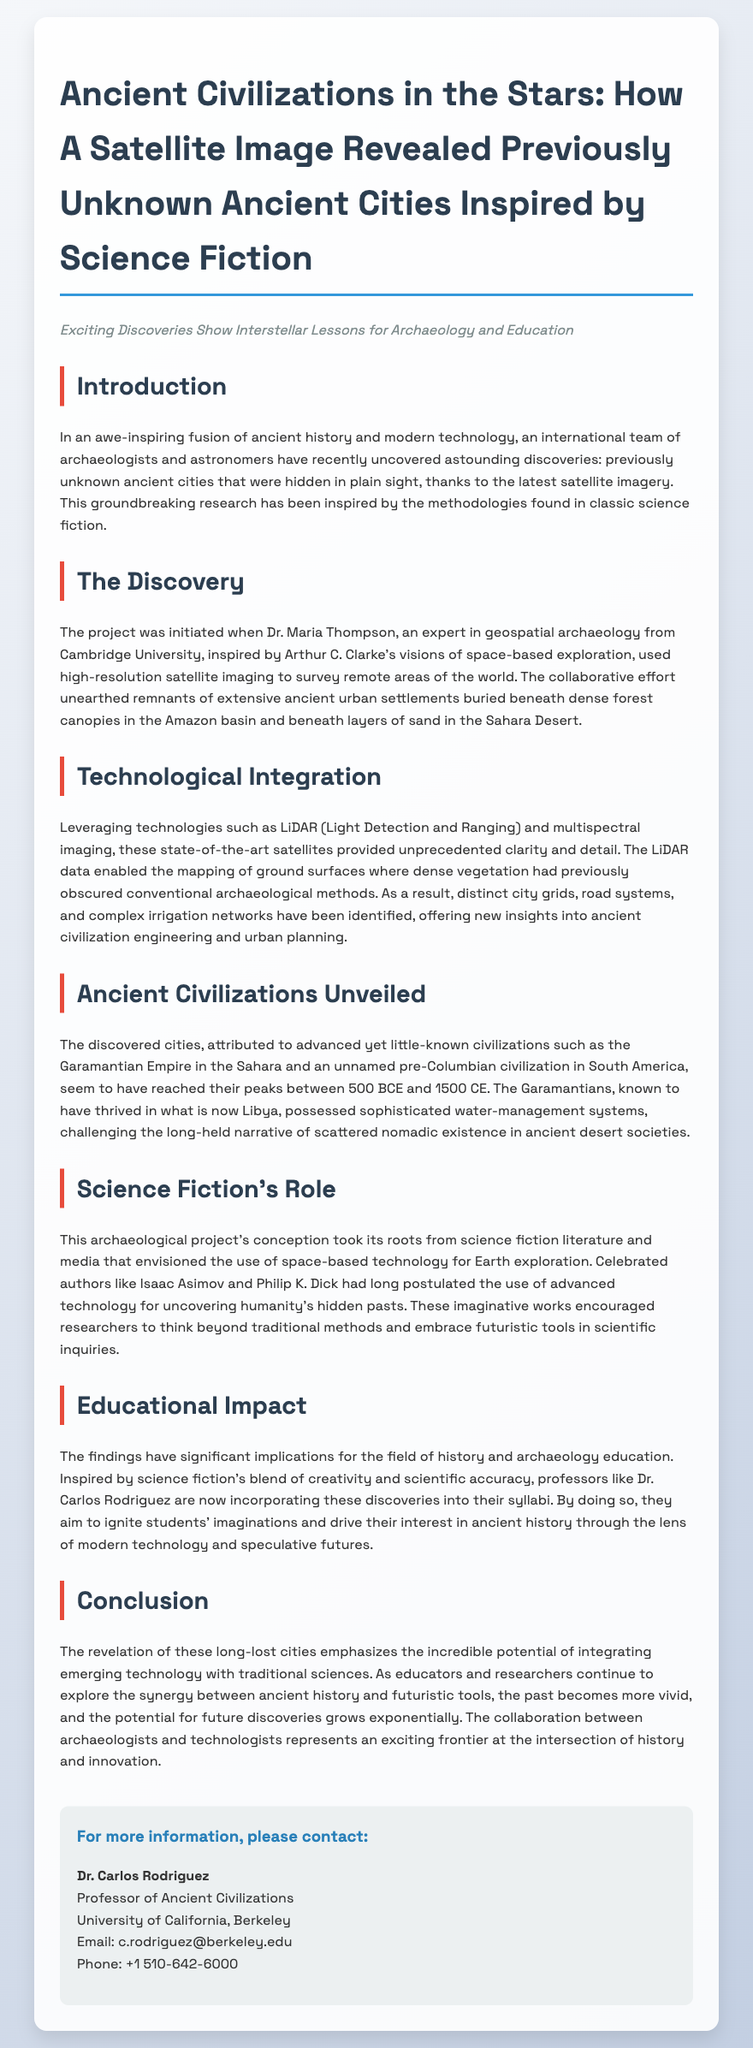What inspired Dr. Maria Thompson's research? The research was inspired by Arthur C. Clarke's visions of space-based exploration.
Answer: Arthur C. Clarke What technologies were leveraged in the project? The project utilized LiDAR (Light Detection and Ranging) and multispectral imaging technologies.
Answer: LiDAR and multispectral imaging Which ancient civilization is mentioned as having sophisticated water-management systems? The Garamantian Empire is noted for its sophisticated water-management systems.
Answer: Garamantian Empire What time frame is indicated for the peak of the discovered cities? The discovered cities reached their peaks between 500 BCE and 1500 CE.
Answer: 500 BCE to 1500 CE Who is the professor incorporating these findings into their syllabi? Professor Dr. Carlos Rodriguez is incorporating the discoveries into his syllabi.
Answer: Dr. Carlos Rodriguez 